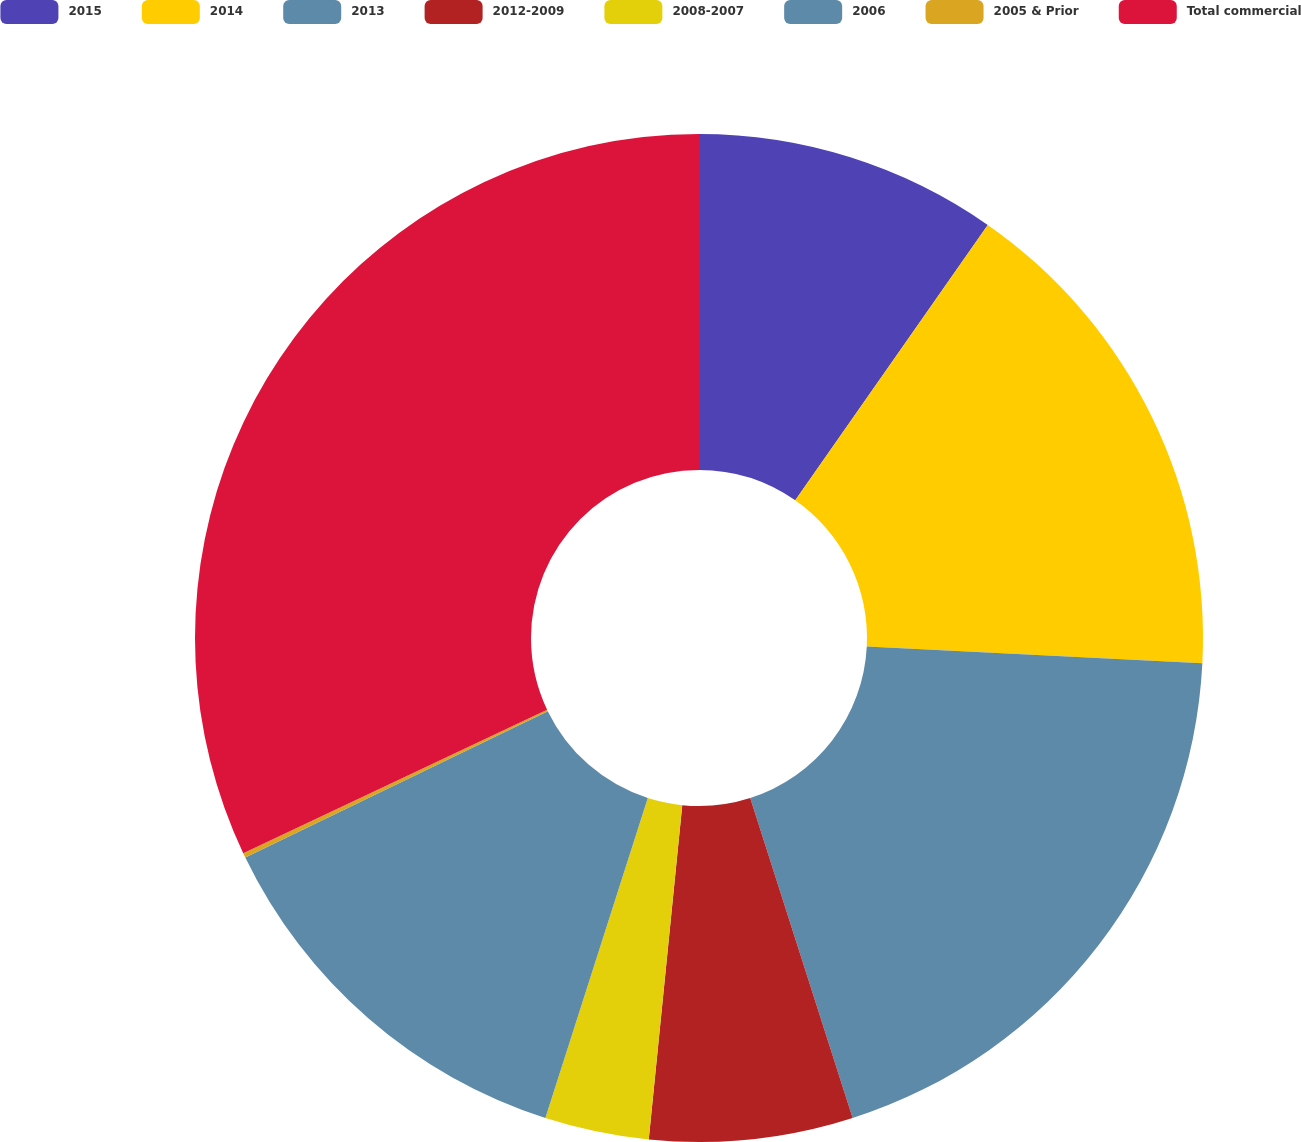Convert chart to OTSL. <chart><loc_0><loc_0><loc_500><loc_500><pie_chart><fcel>2015<fcel>2014<fcel>2013<fcel>2012-2009<fcel>2008-2007<fcel>2006<fcel>2005 & Prior<fcel>Total commercial<nl><fcel>9.71%<fcel>16.09%<fcel>19.27%<fcel>6.52%<fcel>3.34%<fcel>12.9%<fcel>0.15%<fcel>32.02%<nl></chart> 